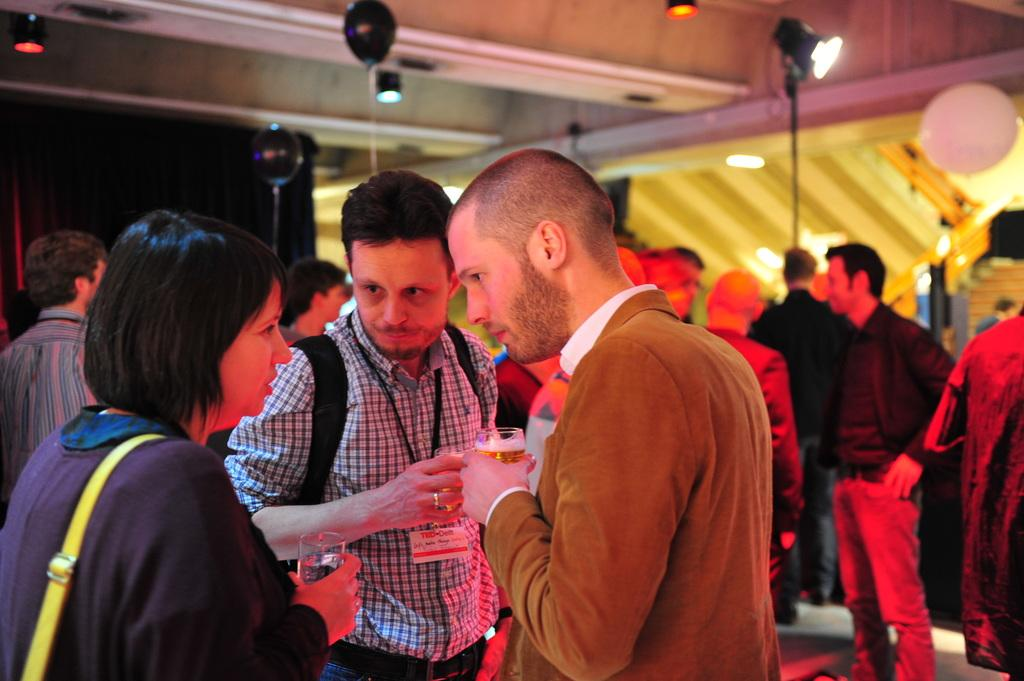What is the main subject in the middle of the image? There is a man standing in the middle of the image. What is the man holding in his hand? The man is holding a wine glass in his hand. Who is standing on the left side of the image? There is a woman standing on the left side of the image. What color is the coat the woman is wearing? The woman is wearing a blue coat. What can be seen on the roof in the image? There are lights on the roof. How many trains can be seen passing by in the image? There are no trains visible in the image. What is the level of digestion of the food the man ate before the image was taken? There is no information about the man's digestion in the image. 